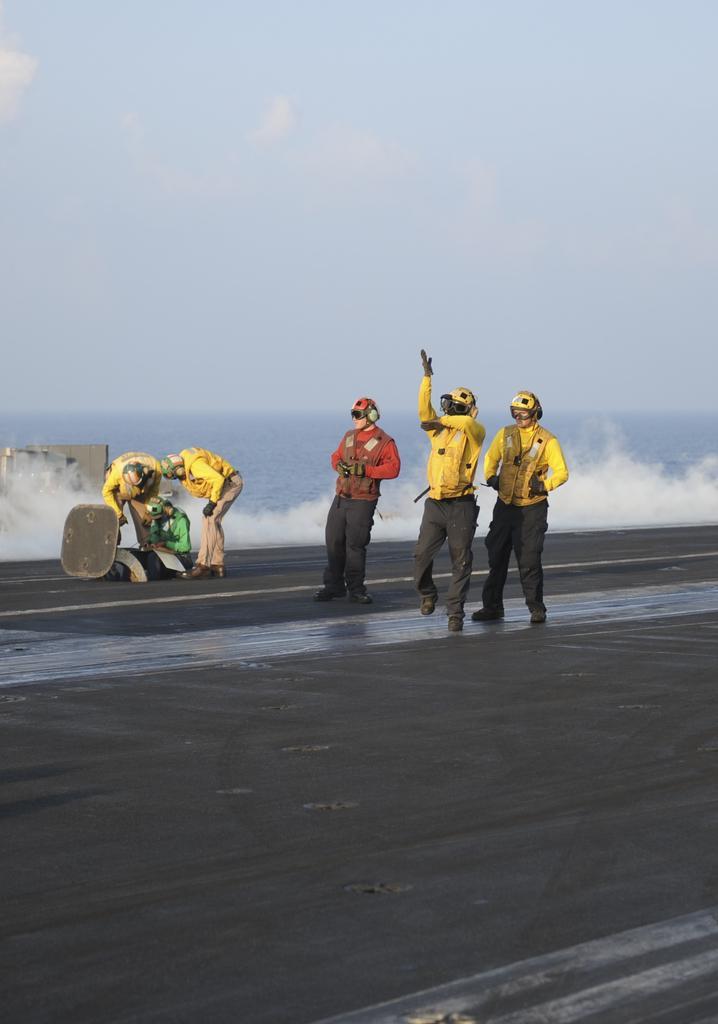In one or two sentences, can you explain what this image depicts? In this image we can see some people wearing headphones and helmets are standing. In the background, we can see water. At the top of the image we can see the sky. 